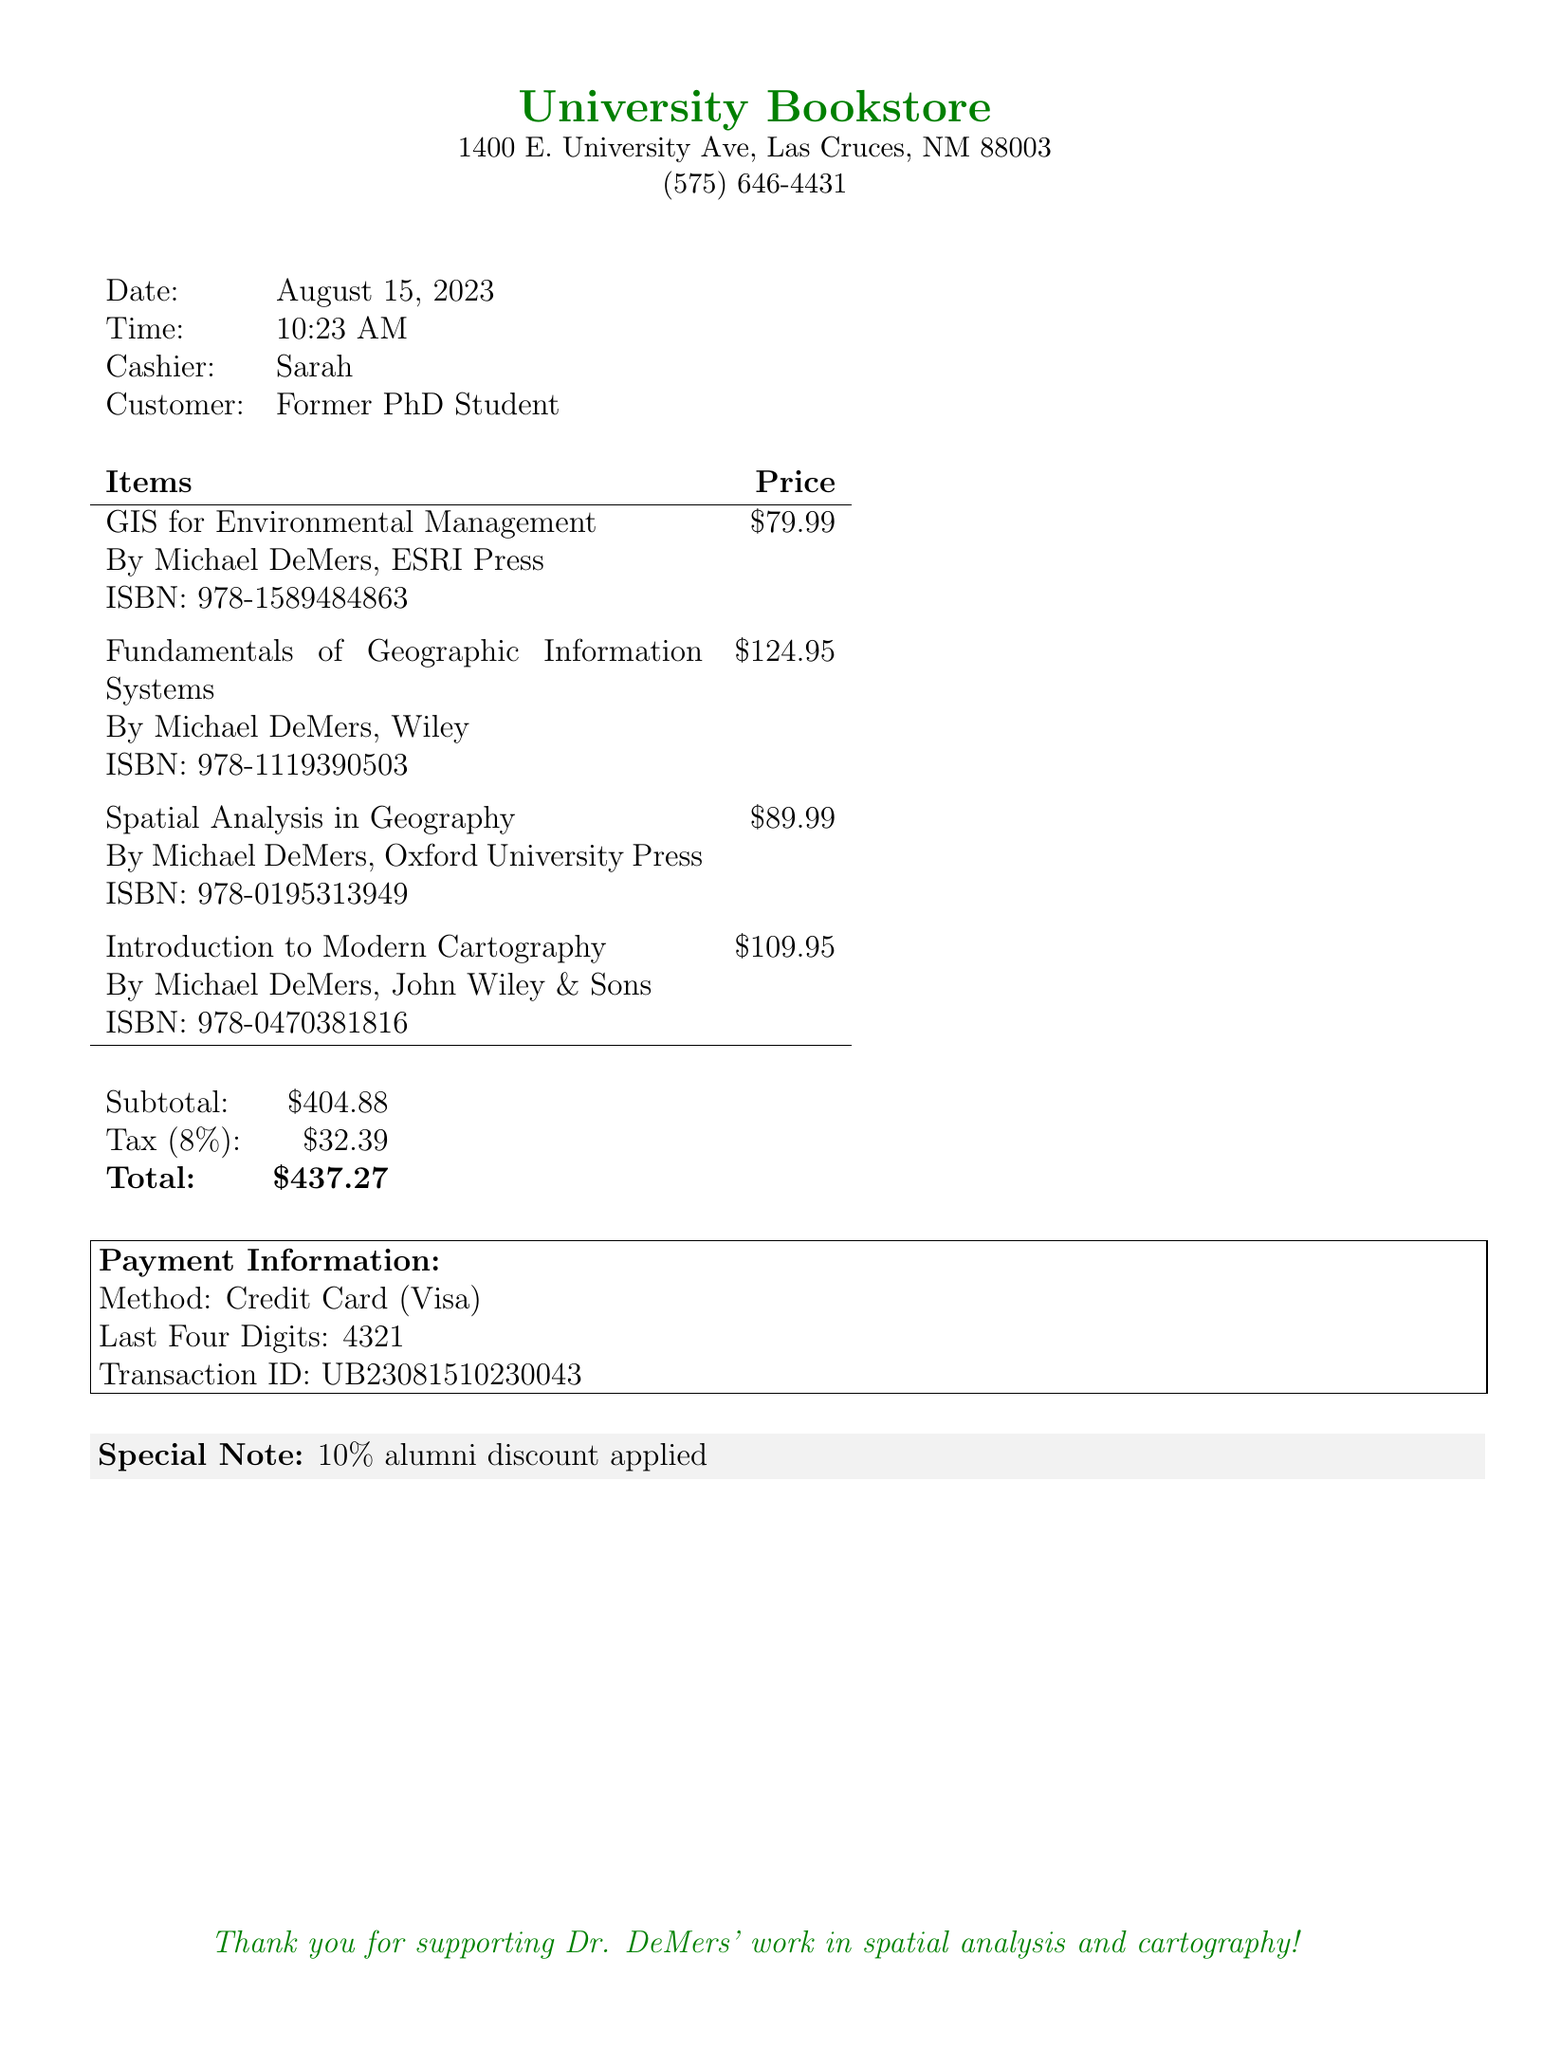what is the date of the transaction? The date of the transaction is explicitly stated in the document.
Answer: August 15, 2023 who was the cashier for this purchase? The cashier's name is provided in the transaction details.
Answer: Sarah how much was the subtotal for the items purchased? The subtotal is listed in the pricing details before tax is added.
Answer: 404.88 what is the total amount charged? The total is the sum of the subtotal and tax, which is clearly specified.
Answer: 437.27 how many textbooks were purchased? The document lists four items that were bought.
Answer: 4 what type of payment was used for the transaction? The payment method is explicitly noted in the document.
Answer: Credit Card which author’s books were purchased? The author of all listed items is mentioned at the beginning of each book description.
Answer: Michael DeMers was an alumni discount applied to the purchase? The document contains a specific note regarding any discounts that were applied.
Answer: Yes what is the transaction ID for this purchase? The transaction ID is provided as a unique identifier in the payment information section.
Answer: UB23081510230043 what is the tax rate applied to the purchase? The tax rate is explicitly mentioned in the pricing breakdown.
Answer: 8% 